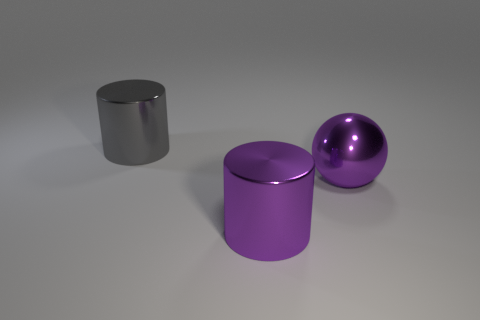Add 2 gray cylinders. How many objects exist? 5 Subtract all spheres. How many objects are left? 2 Add 3 spheres. How many spheres are left? 4 Add 2 blue shiny things. How many blue shiny things exist? 2 Subtract 0 gray blocks. How many objects are left? 3 Subtract all red metallic blocks. Subtract all metal cylinders. How many objects are left? 1 